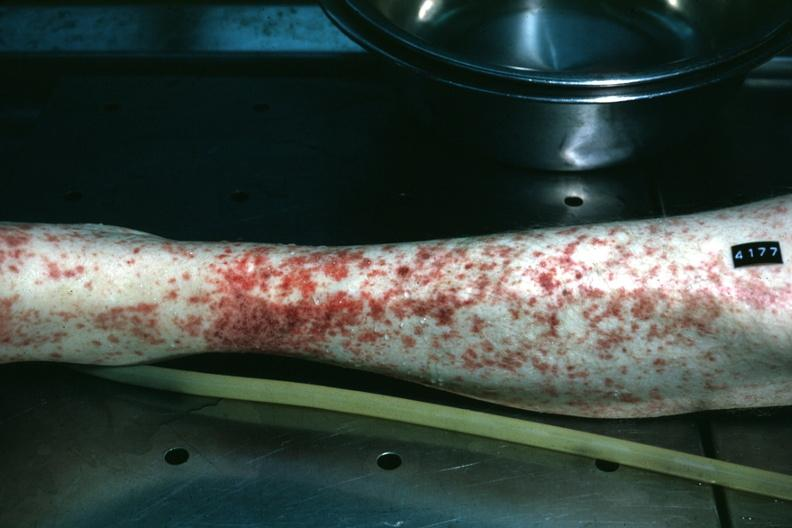does fallopian tube show leg excellent example of skin hemorrhages?
Answer the question using a single word or phrase. No 